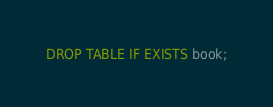Convert code to text. <code><loc_0><loc_0><loc_500><loc_500><_SQL_>DROP TABLE IF EXISTS book;</code> 